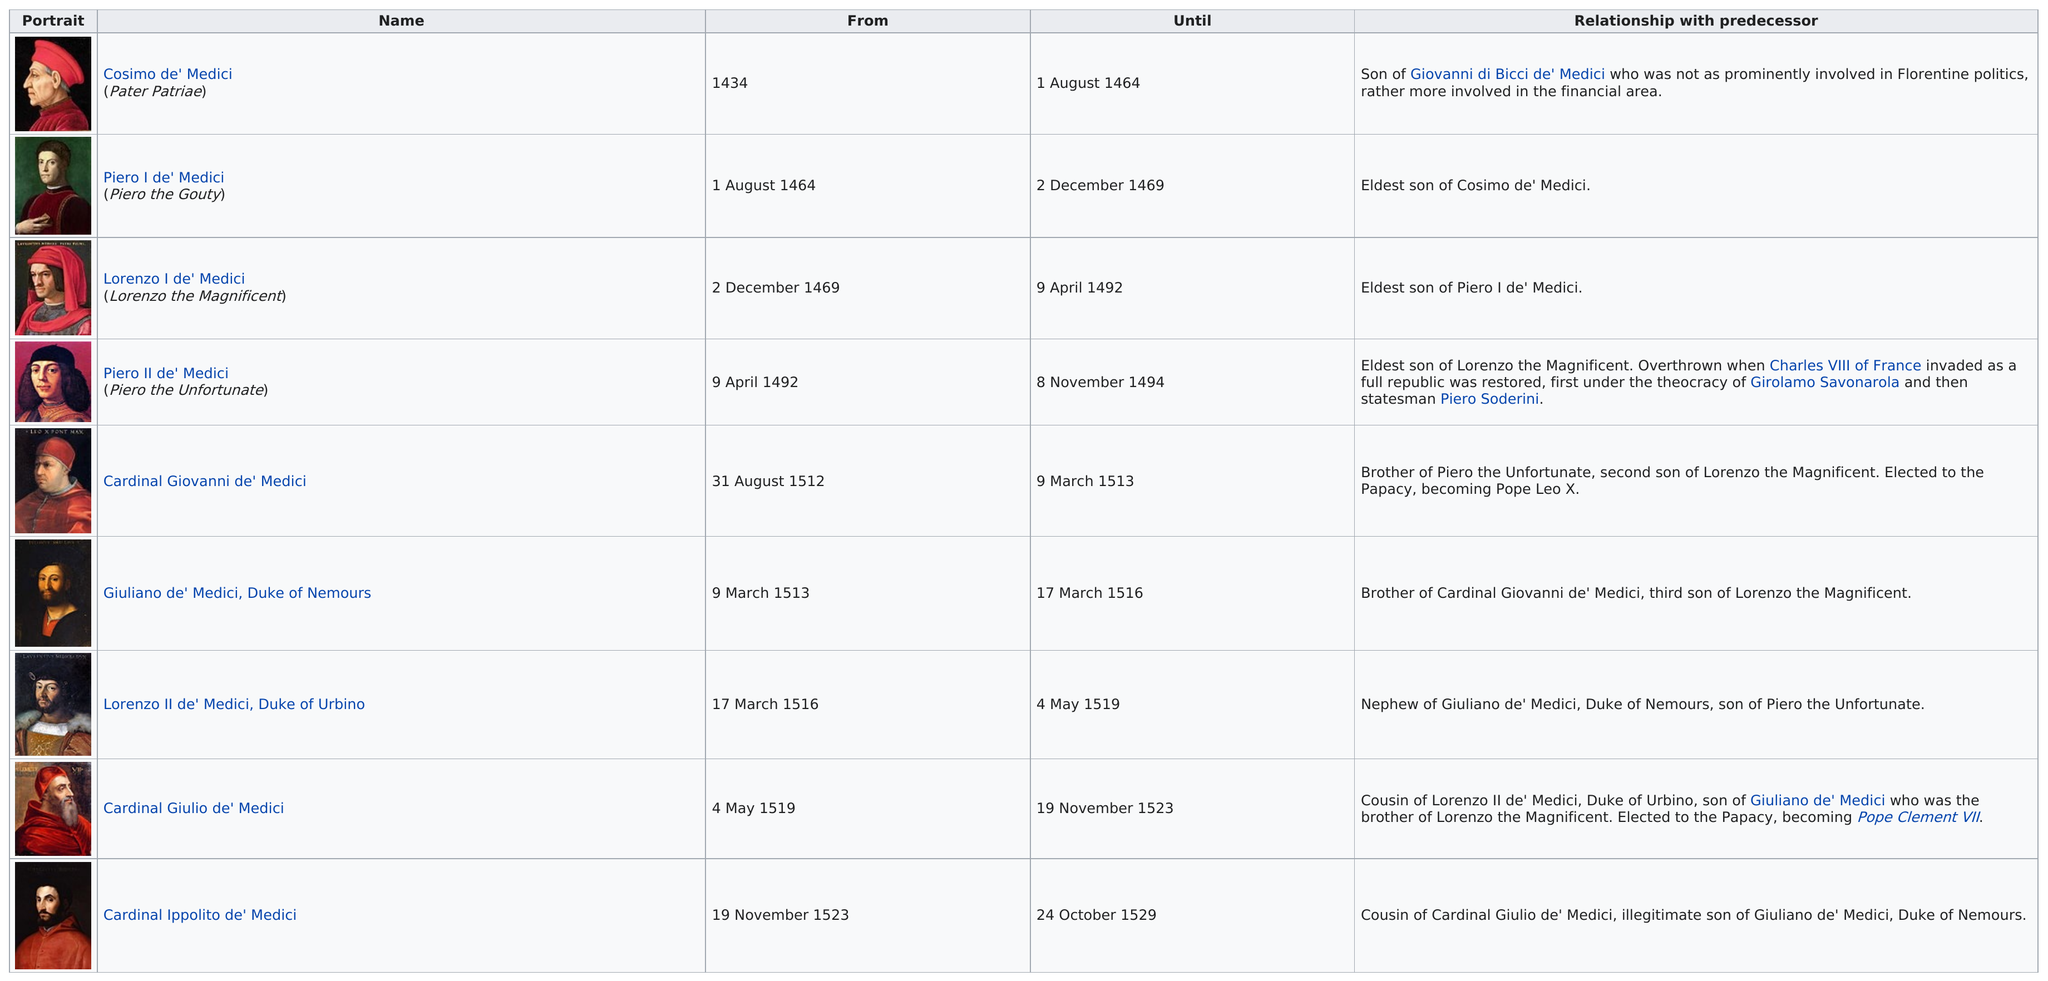Specify some key components in this picture. Only two individuals served as the head of the Medici family for a longer period than Piero I de' Medici. After Cardinal Giulio de' Medici, Giuliano de' Medici served as the head of the Medici family and the duke of Nemours. Six Medicis served after Lorenzo the Magnificent. Piero I de' Medici, also known as Piero the Gouty, was the head after Cosimo de' Medici. Cosimo de' Medici was the first head of the Medici family. 